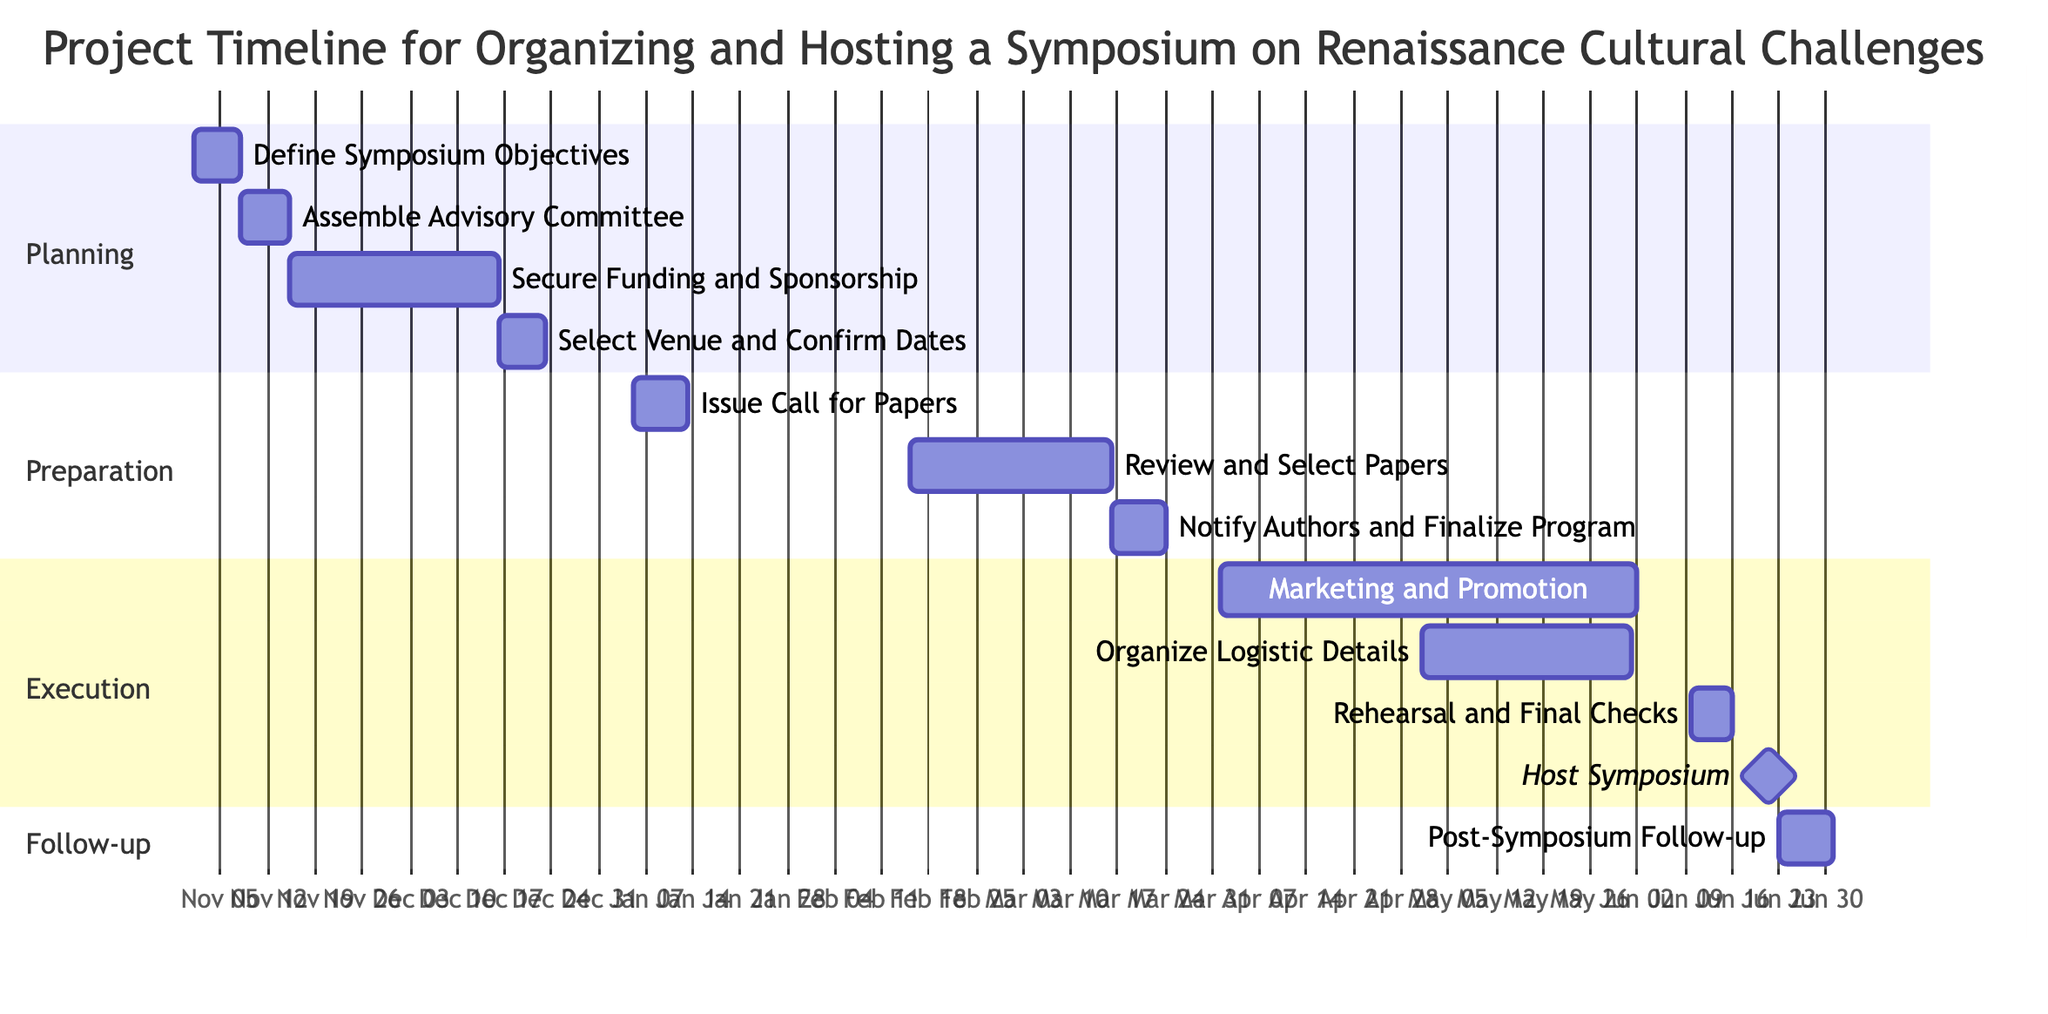What is the duration of the "Define Symposium Objectives" task? The task "Define Symposium Objectives" starts on November 1, 2023, and ends on November 7, 2023. The duration can be calculated as the difference between these two dates, which is 7 days.
Answer: 7 days What is the start date of "Assemble Advisory Committee"? The task "Assemble Advisory Committee" starts immediately after "Define Symposium Objectives," which ends on November 7, 2023. Therefore, "Assemble Advisory Committee" starts on November 8, 2023.
Answer: November 8, 2023 Which task follows "Select Venue and Confirm Dates"? "Select Venue and Confirm Dates" ends on December 22, 2023. The task that follows this, based on the dependencies, is "Issue Call for Papers."
Answer: Issue Call for Papers How many days are allocated for "Marketing and Promotion"? "Marketing and Promotion" starts on April 1, 2024, and ends on June 1, 2024. To find its duration, calculate the difference between these dates, which results in 62 days.
Answer: 62 days What task is dependent on "Review and Select Papers"? The task that is dependent on "Review and Select Papers" is "Notify Authors and Finalize Program." It directly follows after the completion of the papers review process.
Answer: Notify Authors and Finalize Program What is the end date of the "Host Symposium" task? The "Host Symposium" task is scheduled to begin on June 20, 2024, and it lasts for 3 days. Hence, it ends on June 22, 2024.
Answer: June 22, 2024 How many total tasks are included in this Gantt chart? By counting all the tasks listed in the Gantt chart: "Define Symposium Objectives," "Assemble Advisory Committee," "Secure Funding and Sponsorship," "Select Venue and Confirm Dates," "Issue Call for Papers," "Review and Select Papers," "Notify Authors and Finalize Program," "Marketing and Promotion," "Organize Logistic Details," "Rehearsal and Final Checks," "Host Symposium," and "Post-Symposium Follow-up," there are a total of 12 tasks.
Answer: 12 tasks What starts immediately after "Notify Authors and Finalize Program"? The tasks "Marketing and Promotion" and "Organize Logistic Details" both start immediately after "Notify Authors and Finalize Program." These tasks run simultaneously, showing parallel processes in the Gantt chart.
Answer: Marketing and Promotion, Organize Logistic Details What is the total duration for the "Post-Symposium Follow-up"? "Post-Symposium Follow-up" begins on June 23, 2024, and ends on June 30, 2024. The duration is calculated as the difference between these dates, which yields 8 days.
Answer: 8 days 